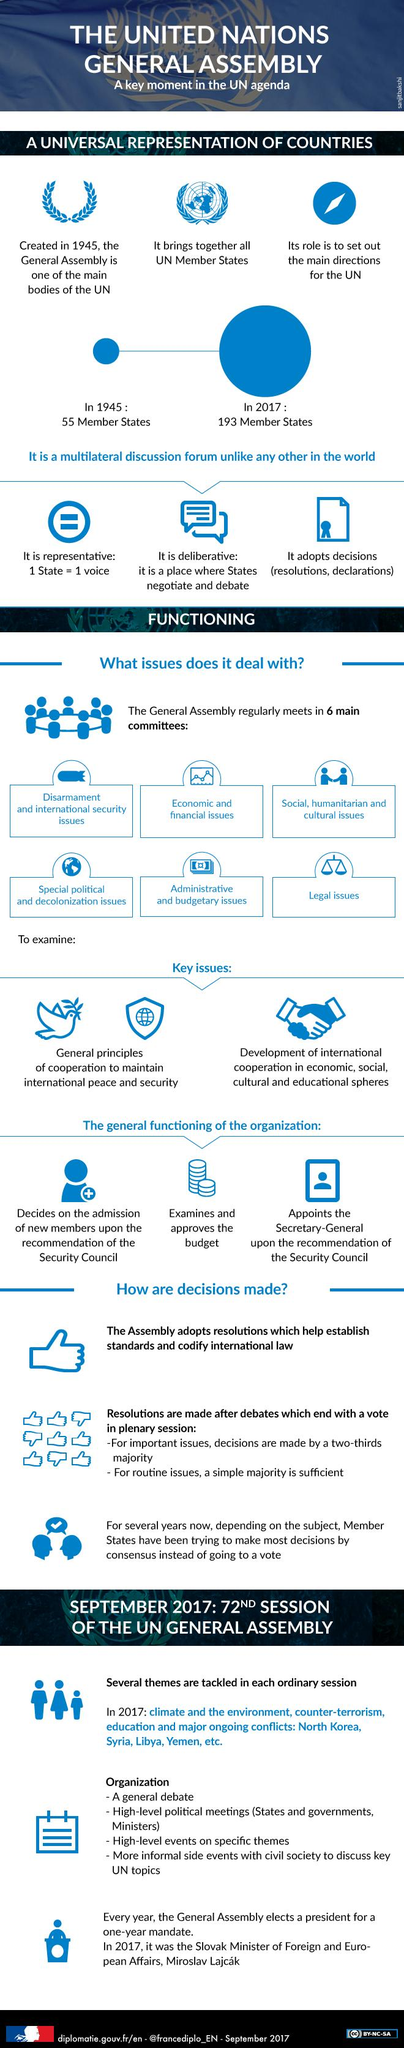Specify some key components in this picture. As of 1945, there have been 138 member states that have increased in the United Nations. As of 2017, there were 4 countries that were experiencing major ongoing conflicts. The United Nations addresses at least two key issues. 